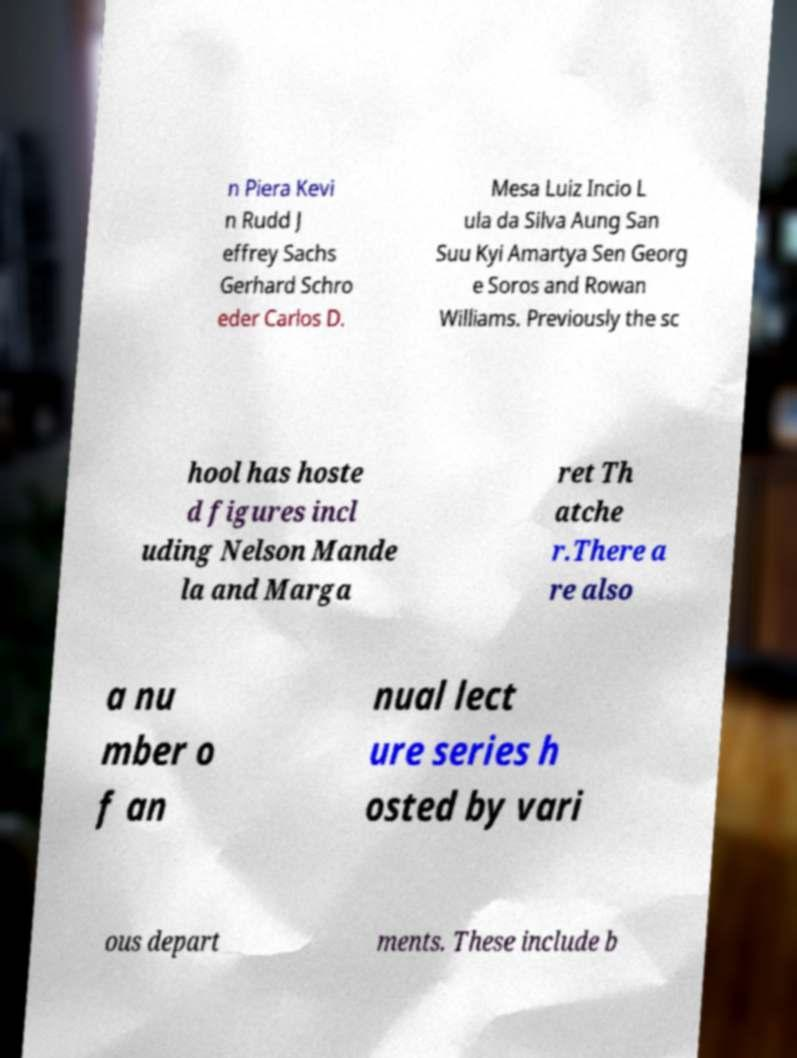Could you extract and type out the text from this image? n Piera Kevi n Rudd J effrey Sachs Gerhard Schro eder Carlos D. Mesa Luiz Incio L ula da Silva Aung San Suu Kyi Amartya Sen Georg e Soros and Rowan Williams. Previously the sc hool has hoste d figures incl uding Nelson Mande la and Marga ret Th atche r.There a re also a nu mber o f an nual lect ure series h osted by vari ous depart ments. These include b 